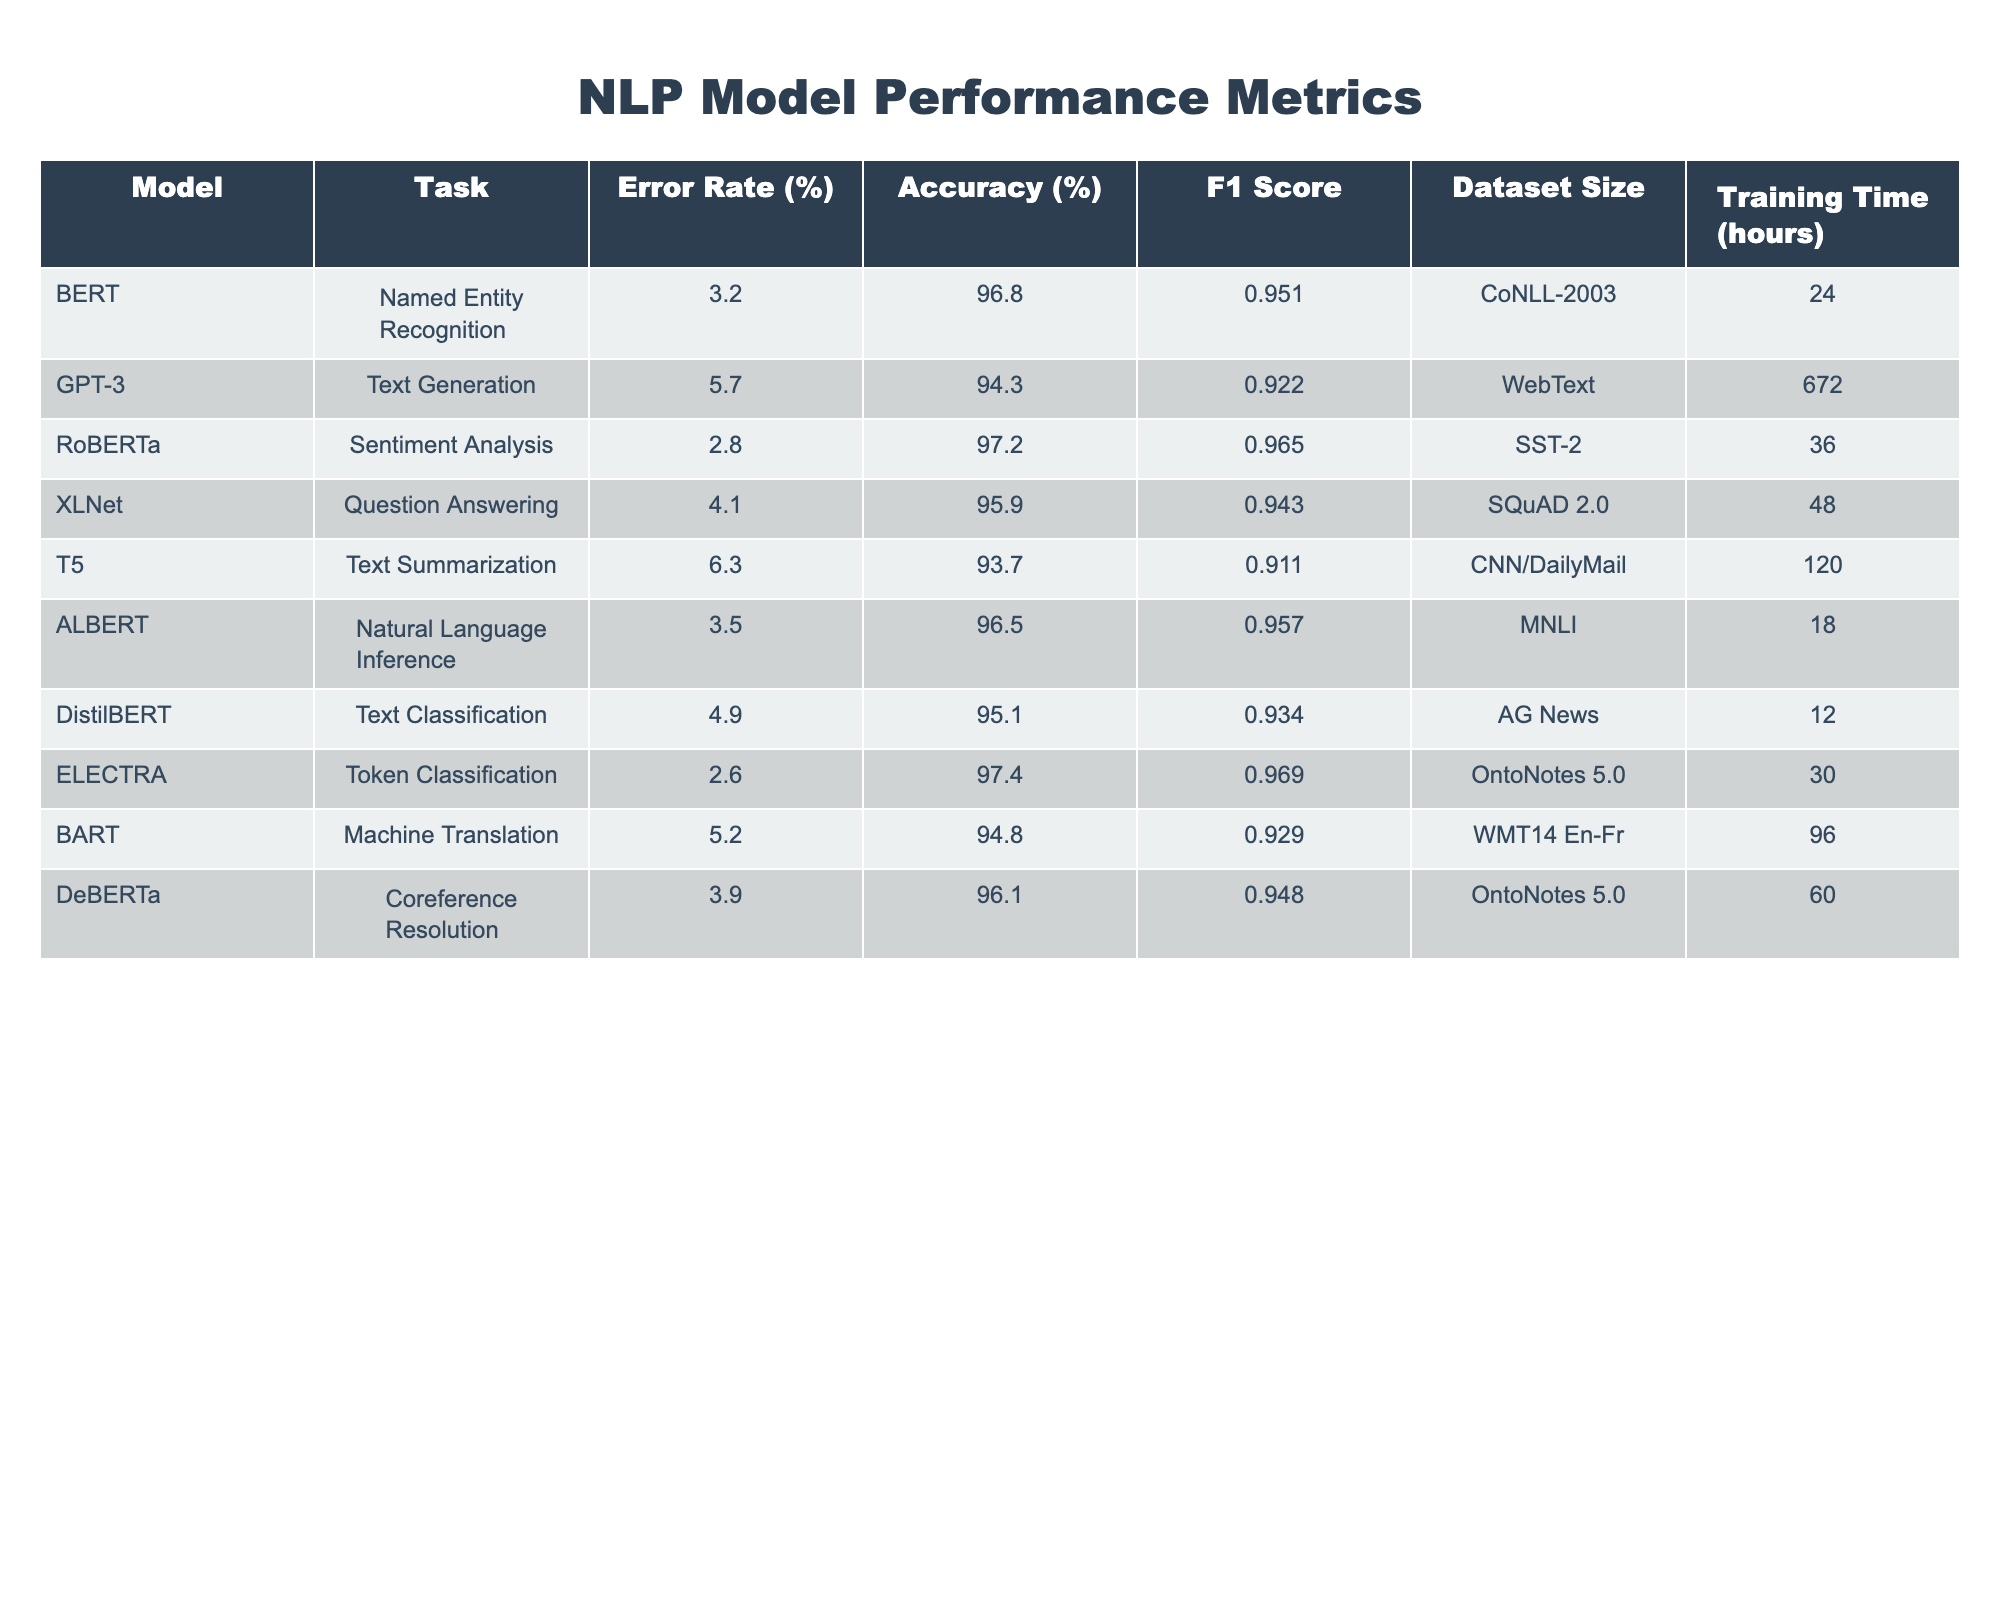What is the error rate for BERT in Named Entity Recognition? The table shows that BERT has an error rate of 3.2% for the Named Entity Recognition task.
Answer: 3.2% Which model has the highest accuracy? The table indicates that ELECTRA has the highest accuracy at 97.4%.
Answer: 97.4% What is the average training time for the models listed? The training times for the models are 24, 672, 36, 48, 120, 18, 12, 30, 96, and 60 hours. The total is 72 + 672 + 36 + 48 + 120 + 18 + 12 + 30 + 96 + 60 = 960 hours. The average is 960 / 10 = 96 hours.
Answer: 96 hours Is the F1 Score for RoBERTa higher than that for BERT? The F1 Score for RoBERTa is 0.965 while BERT's F1 Score is 0.951. Therefore, it is true that RoBERTa's F1 Score is higher than BERT's.
Answer: Yes Which model has the lowest error rate and what is that rate? Looking at the table, ELECTRA has the lowest error rate of 2.6%.
Answer: 2.6% What is the difference in accuracy between the best and worst performing models? The best accuracy is from ELECTRA at 97.4% and the worst is from T5 at 93.7%. The difference is 97.4 - 93.7 = 3.7%.
Answer: 3.7% How many models have an error rate less than 4%? The models with error rates less than 4% are BERT (3.2%), RoBERTa (2.8%), and ELECTRA (2.6%). This makes a total of three models.
Answer: 3 models Does the training time correlate with error rate in all cases? A detailed look at the error rates and training times shows that longer training times do not consistently result in lower error rates, thus the statement is false.
Answer: No What is the sum of the error rates for all models? The error rates are 3.2, 5.7, 2.8, 4.1, 6.3, 3.5, 4.9, 2.6, 5.2, and 3.9. Adding them together gives: 3.2 + 5.7 + 2.8 + 4.1 + 6.3 + 3.5 + 4.9 + 2.6 + 5.2 + 3.9 = 38.2%.
Answer: 38.2% Which model has the longest training time and how long was it? From the table, GPT-3 has the longest training time listed at 672 hours.
Answer: 672 hours 